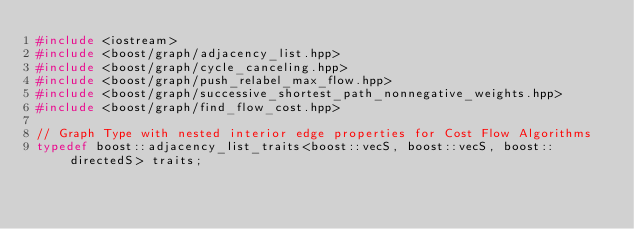Convert code to text. <code><loc_0><loc_0><loc_500><loc_500><_C++_>#include <iostream>
#include <boost/graph/adjacency_list.hpp>
#include <boost/graph/cycle_canceling.hpp>
#include <boost/graph/push_relabel_max_flow.hpp>
#include <boost/graph/successive_shortest_path_nonnegative_weights.hpp>
#include <boost/graph/find_flow_cost.hpp>

// Graph Type with nested interior edge properties for Cost Flow Algorithms
typedef boost::adjacency_list_traits<boost::vecS, boost::vecS, boost::directedS> traits;</code> 